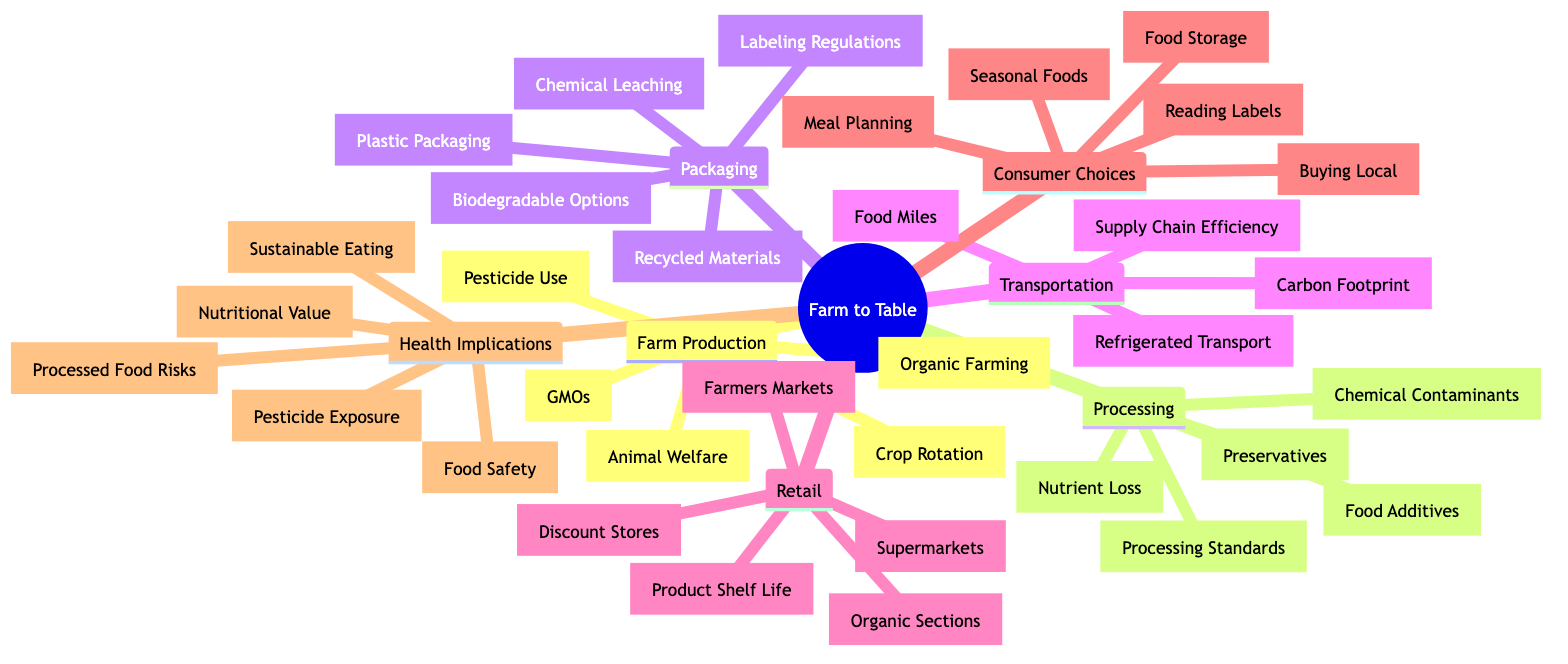What are the five elements of the supply chain from farm to table? The diagram has the main elements of the supply chain categorized under "Farm Production," "Processing," "Packaging," "Transportation," "Retail," "Consumer Choices," and "Health Implications." There are seven distinct elements.
Answer: seven Which element addresses the use of 'Pesticides'? The node detailing 'Pesticide Use' is a part of the 'Farm Production' element, which encompasses various practices and methods used in the farming process.
Answer: Farm Production How many details are associated with 'Packaging'? The 'Packaging' element contains five specific details that relate to different aspects of food packaging. These include diverse materials and regulatory concerns.
Answer: five What health concern is highlighted in relation to processed foods? The 'Health Implications' section mentions 'Processed Foods Health Risks,' addressing the potential adverse effects of consuming such foods.
Answer: Processed Foods Health Risks What factors are listed under 'Transportation'? Under the 'Transportation' category, the details include 'Refrigerated Transport,' 'Carbon Footprint,' 'Food Miles,' and 'Supply Chain Efficiency,' which collectively illustrate the logistics of food transport.
Answer: Refrigerated Transport, Carbon Footprint, Food Miles, Supply Chain Efficiency Which consumer choice encourages purchasing food directly from farmers? The 'Consumer Choices' element includes 'Buying Local', which specifically promotes obtaining food directly from local producers rather than from large supermarkets or processed sources.
Answer: Buying Local What relationship exists between 'Organic Farming' and 'Health Implications'? 'Organic Farming' is a part of 'Farm Production', which connects to 'Health Implications' through aspects like 'Nutritional Value' and 'Pesticide Exposure', indicating that farming practices influence health outcomes.
Answer: Farm Production to Health Implications How does 'Food Processing' impact nutrient levels in food? The 'Processing' element mentions 'Nutrient Loss During Processing', indicating that processing food can diminish its nutritional content. This connection reflects a direct impact of processing on food quality.
Answer: Nutrient Loss During Processing Which aspect of 'Retail' could affect the freshness of produce? Among the details in 'Retail', 'Product Shelf Life' directly influences how long produce remains fresh and appealing for consumers, making it crucial for food quality at point of sale.
Answer: Product Shelf Life 